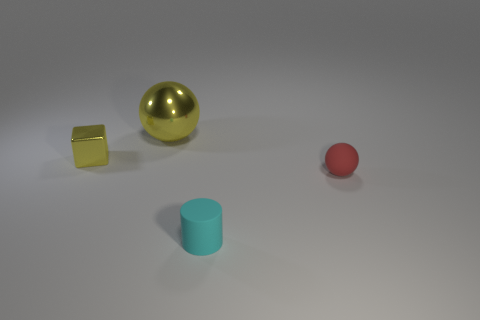Add 2 cyan shiny objects. How many objects exist? 6 Subtract all cubes. How many objects are left? 3 Add 3 big metallic cylinders. How many big metallic cylinders exist? 3 Subtract 0 cyan cubes. How many objects are left? 4 Subtract all big yellow rubber balls. Subtract all tiny cyan objects. How many objects are left? 3 Add 3 large yellow objects. How many large yellow objects are left? 4 